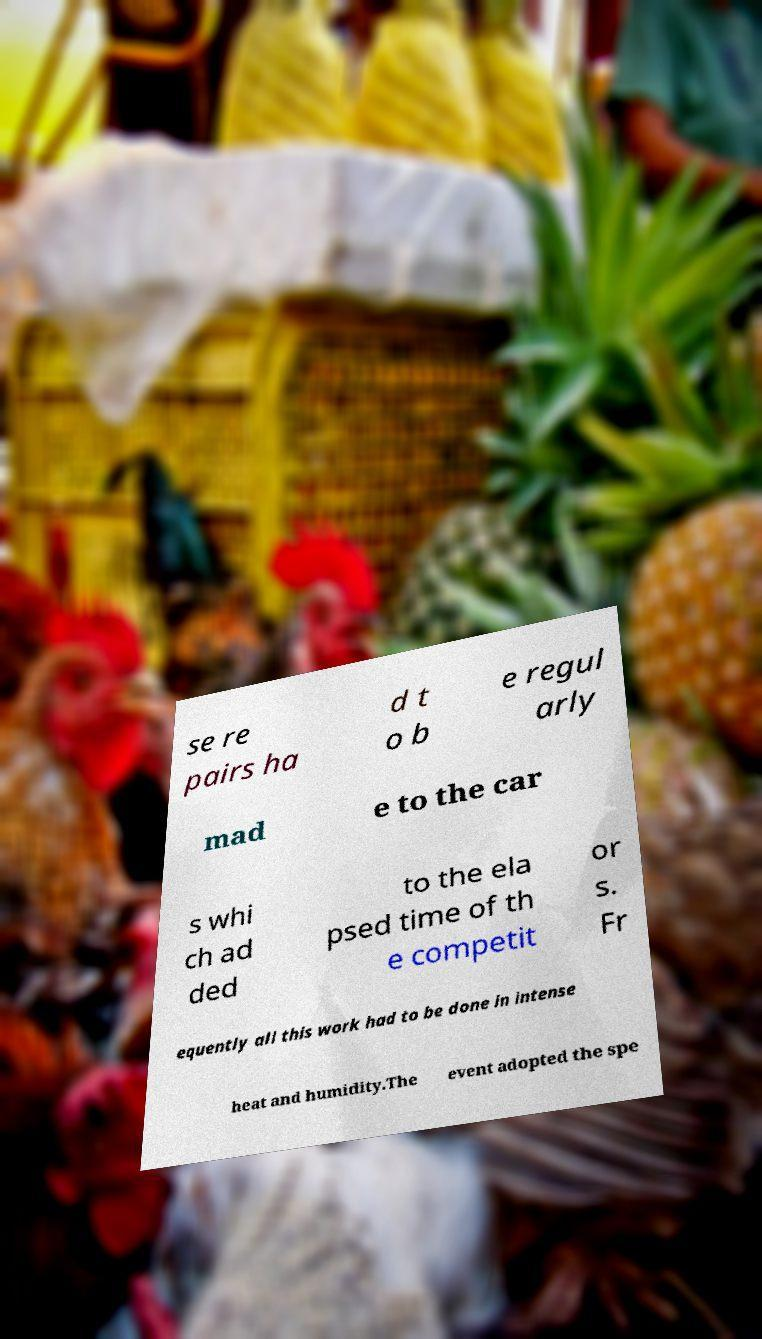Please read and relay the text visible in this image. What does it say? se re pairs ha d t o b e regul arly mad e to the car s whi ch ad ded to the ela psed time of th e competit or s. Fr equently all this work had to be done in intense heat and humidity.The event adopted the spe 